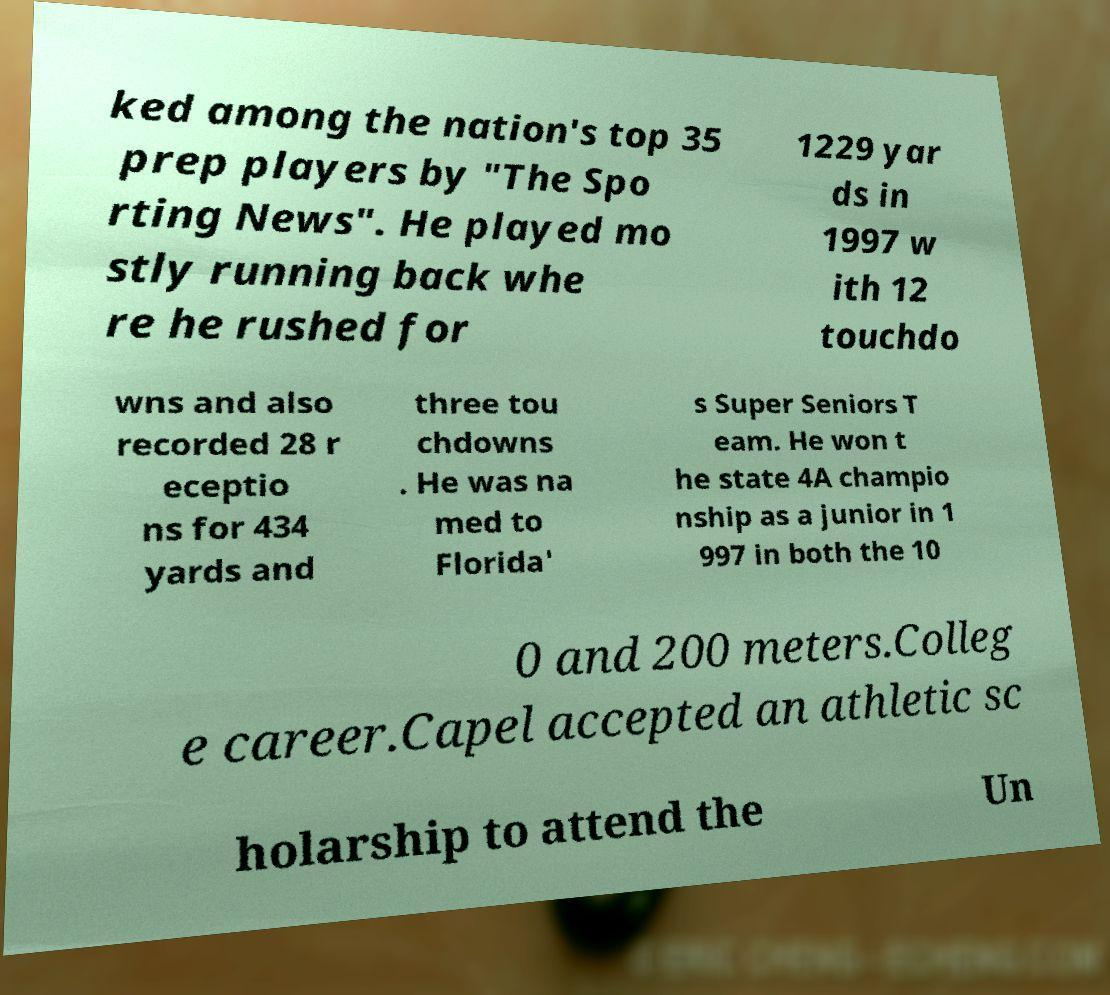I need the written content from this picture converted into text. Can you do that? ked among the nation's top 35 prep players by "The Spo rting News". He played mo stly running back whe re he rushed for 1229 yar ds in 1997 w ith 12 touchdo wns and also recorded 28 r eceptio ns for 434 yards and three tou chdowns . He was na med to Florida' s Super Seniors T eam. He won t he state 4A champio nship as a junior in 1 997 in both the 10 0 and 200 meters.Colleg e career.Capel accepted an athletic sc holarship to attend the Un 